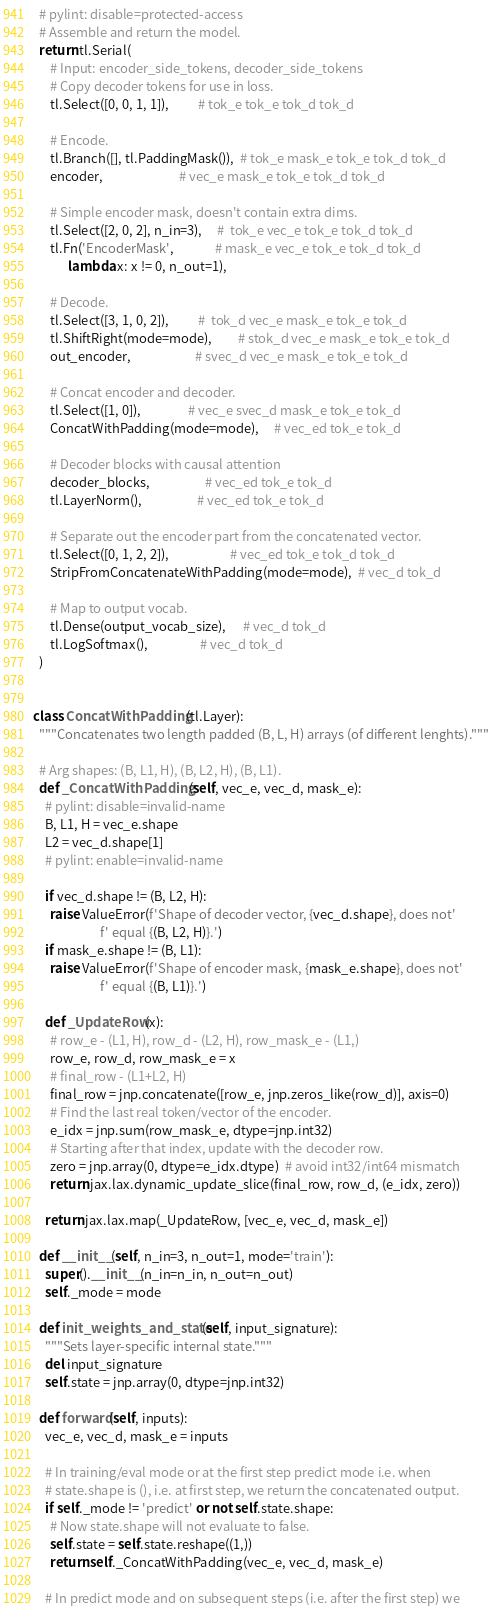Convert code to text. <code><loc_0><loc_0><loc_500><loc_500><_Python_>  # pylint: disable=protected-access
  # Assemble and return the model.
  return tl.Serial(
      # Input: encoder_side_tokens, decoder_side_tokens
      # Copy decoder tokens for use in loss.
      tl.Select([0, 0, 1, 1]),          # tok_e tok_e tok_d tok_d

      # Encode.
      tl.Branch([], tl.PaddingMask()),  # tok_e mask_e tok_e tok_d tok_d
      encoder,                          # vec_e mask_e tok_e tok_d tok_d

      # Simple encoder mask, doesn't contain extra dims.
      tl.Select([2, 0, 2], n_in=3),     #  tok_e vec_e tok_e tok_d tok_d
      tl.Fn('EncoderMask',              # mask_e vec_e tok_e tok_d tok_d
            lambda x: x != 0, n_out=1),

      # Decode.
      tl.Select([3, 1, 0, 2]),          #  tok_d vec_e mask_e tok_e tok_d
      tl.ShiftRight(mode=mode),         # stok_d vec_e mask_e tok_e tok_d
      out_encoder,                      # svec_d vec_e mask_e tok_e tok_d

      # Concat encoder and decoder.
      tl.Select([1, 0]),                # vec_e svec_d mask_e tok_e tok_d
      ConcatWithPadding(mode=mode),     # vec_ed tok_e tok_d

      # Decoder blocks with causal attention
      decoder_blocks,                   # vec_ed tok_e tok_d
      tl.LayerNorm(),                   # vec_ed tok_e tok_d

      # Separate out the encoder part from the concatenated vector.
      tl.Select([0, 1, 2, 2]),                     # vec_ed tok_e tok_d tok_d
      StripFromConcatenateWithPadding(mode=mode),  # vec_d tok_d

      # Map to output vocab.
      tl.Dense(output_vocab_size),      # vec_d tok_d
      tl.LogSoftmax(),                  # vec_d tok_d
  )


class ConcatWithPadding(tl.Layer):
  """Concatenates two length padded (B, L, H) arrays (of different lenghts)."""

  # Arg shapes: (B, L1, H), (B, L2, H), (B, L1).
  def _ConcatWithPadding(self, vec_e, vec_d, mask_e):
    # pylint: disable=invalid-name
    B, L1, H = vec_e.shape
    L2 = vec_d.shape[1]
    # pylint: enable=invalid-name

    if vec_d.shape != (B, L2, H):
      raise ValueError(f'Shape of decoder vector, {vec_d.shape}, does not'
                       f' equal {(B, L2, H)}.')
    if mask_e.shape != (B, L1):
      raise ValueError(f'Shape of encoder mask, {mask_e.shape}, does not'
                       f' equal {(B, L1)}.')

    def _UpdateRow(x):
      # row_e - (L1, H), row_d - (L2, H), row_mask_e - (L1,)
      row_e, row_d, row_mask_e = x
      # final_row - (L1+L2, H)
      final_row = jnp.concatenate([row_e, jnp.zeros_like(row_d)], axis=0)
      # Find the last real token/vector of the encoder.
      e_idx = jnp.sum(row_mask_e, dtype=jnp.int32)
      # Starting after that index, update with the decoder row.
      zero = jnp.array(0, dtype=e_idx.dtype)  # avoid int32/int64 mismatch
      return jax.lax.dynamic_update_slice(final_row, row_d, (e_idx, zero))

    return jax.lax.map(_UpdateRow, [vec_e, vec_d, mask_e])

  def __init__(self, n_in=3, n_out=1, mode='train'):
    super().__init__(n_in=n_in, n_out=n_out)
    self._mode = mode

  def init_weights_and_state(self, input_signature):
    """Sets layer-specific internal state."""
    del input_signature
    self.state = jnp.array(0, dtype=jnp.int32)

  def forward(self, inputs):
    vec_e, vec_d, mask_e = inputs

    # In training/eval mode or at the first step predict mode i.e. when
    # state.shape is (), i.e. at first step, we return the concatenated output.
    if self._mode != 'predict' or not self.state.shape:
      # Now state.shape will not evaluate to false.
      self.state = self.state.reshape((1,))
      return self._ConcatWithPadding(vec_e, vec_d, mask_e)

    # In predict mode and on subsequent steps (i.e. after the first step) we</code> 